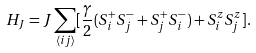<formula> <loc_0><loc_0><loc_500><loc_500>H _ { J } = J \sum _ { \langle i j \rangle } [ \frac { \gamma } { 2 } ( S _ { i } ^ { + } S _ { j } ^ { - } + S _ { j } ^ { + } S _ { i } ^ { - } ) + S _ { i } ^ { z } S _ { j } ^ { z } ] .</formula> 